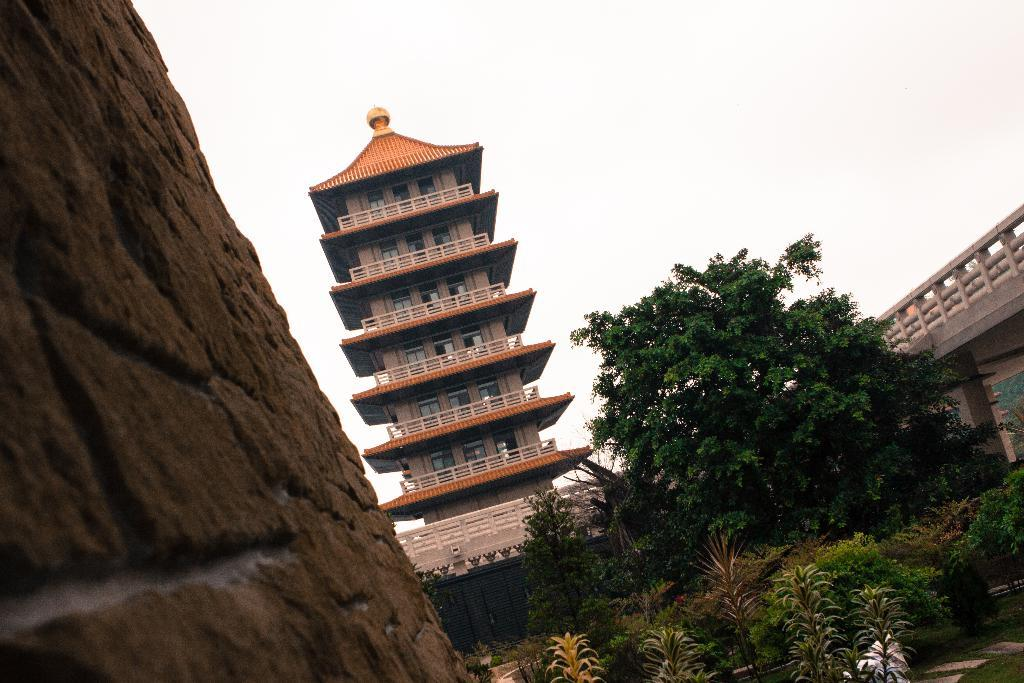What type of structure is visible in the image? There is a building in the image. What natural elements can be seen in the image? There are plants and trees in the image. Where is the bridge located in the image? The bridge is on the right side of the image. What geographical feature is on the left side of the image? There is a mountain on the left side of the image. How many leaves are on the list in the image? There is no list or leaves present in the image. What is the temperature in the image? The image does not provide information about the temperature or heat. 